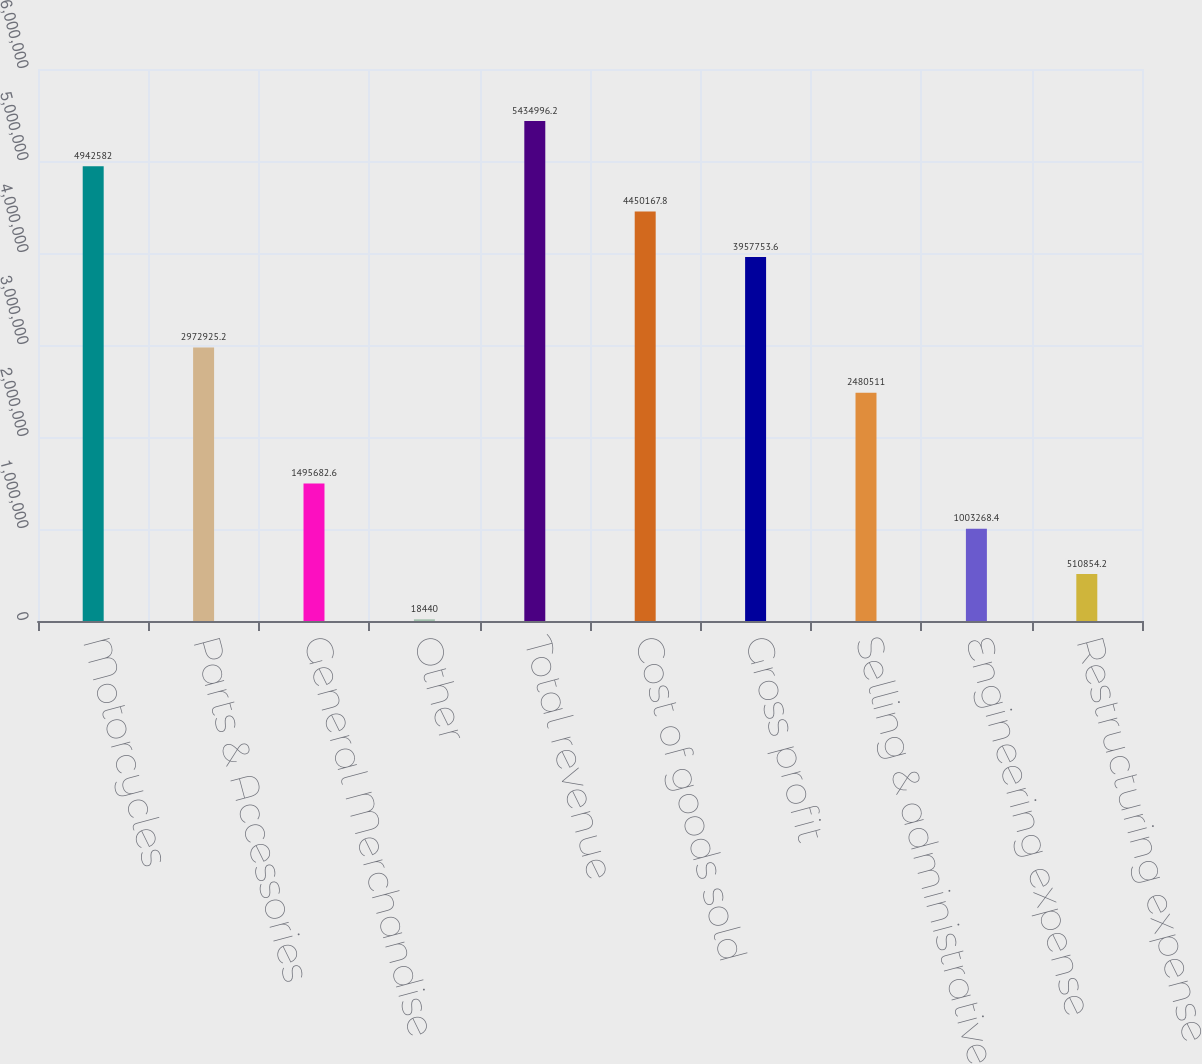<chart> <loc_0><loc_0><loc_500><loc_500><bar_chart><fcel>Motorcycles<fcel>Parts & Accessories<fcel>General Merchandise<fcel>Other<fcel>Total revenue<fcel>Cost of goods sold<fcel>Gross profit<fcel>Selling & administrative<fcel>Engineering expense<fcel>Restructuring expense<nl><fcel>4.94258e+06<fcel>2.97293e+06<fcel>1.49568e+06<fcel>18440<fcel>5.435e+06<fcel>4.45017e+06<fcel>3.95775e+06<fcel>2.48051e+06<fcel>1.00327e+06<fcel>510854<nl></chart> 